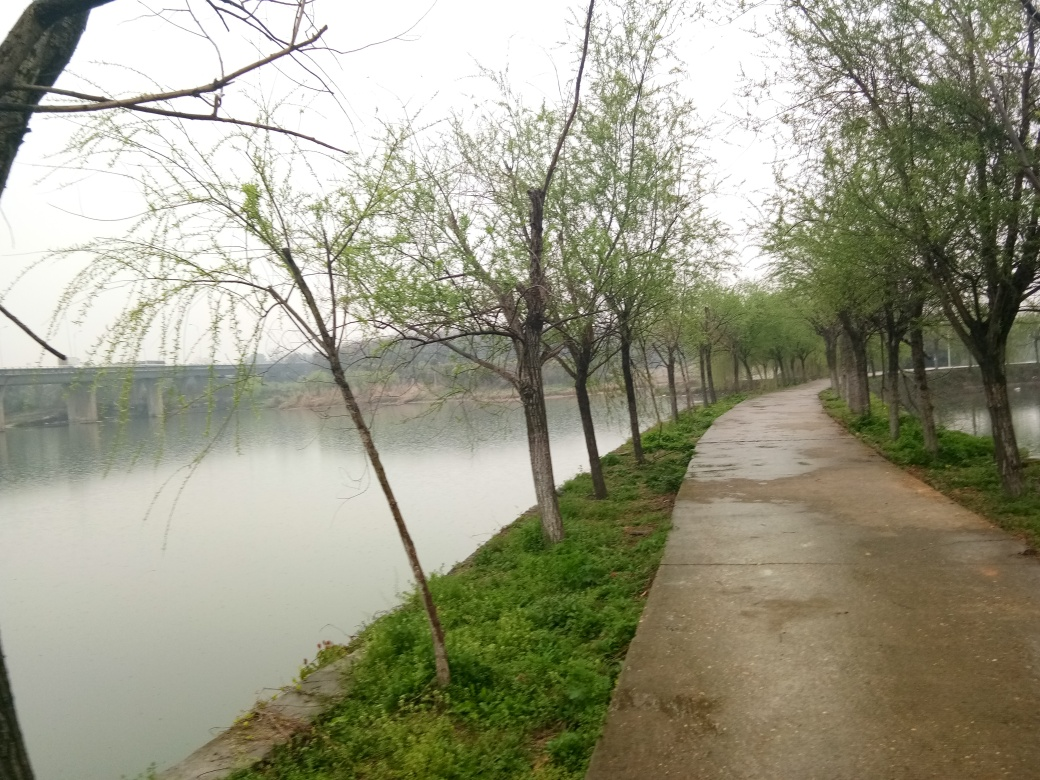What time of year does this image seem to represent, and what clues lead to that conclusion? The image suggests early spring as the most likely time of year. This is indicated by the presence of budding leaves on the trees, the dampness of the pathway suggestive of recent rains, and the overall gray sky which is common in springtime before the full bloom of the season. 